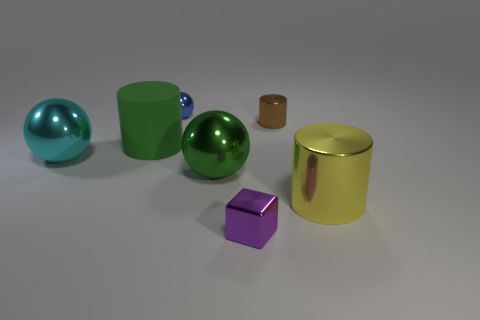Subtract all shiny cylinders. How many cylinders are left? 1 Add 1 large yellow things. How many objects exist? 8 Subtract all blocks. How many objects are left? 6 Add 6 yellow metal objects. How many yellow metal objects exist? 7 Subtract 1 yellow cylinders. How many objects are left? 6 Subtract all large gray metal things. Subtract all green rubber things. How many objects are left? 6 Add 1 large cyan metallic balls. How many large cyan metallic balls are left? 2 